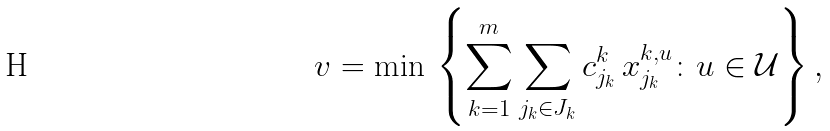<formula> <loc_0><loc_0><loc_500><loc_500>v = \min \, \left \{ \sum _ { k = 1 } ^ { m } \sum _ { j _ { k } \in J _ { k } } c _ { j _ { k } } ^ { k } \, x _ { j _ { k } } ^ { k , u } \colon u \in \mathcal { U } \right \} ,</formula> 